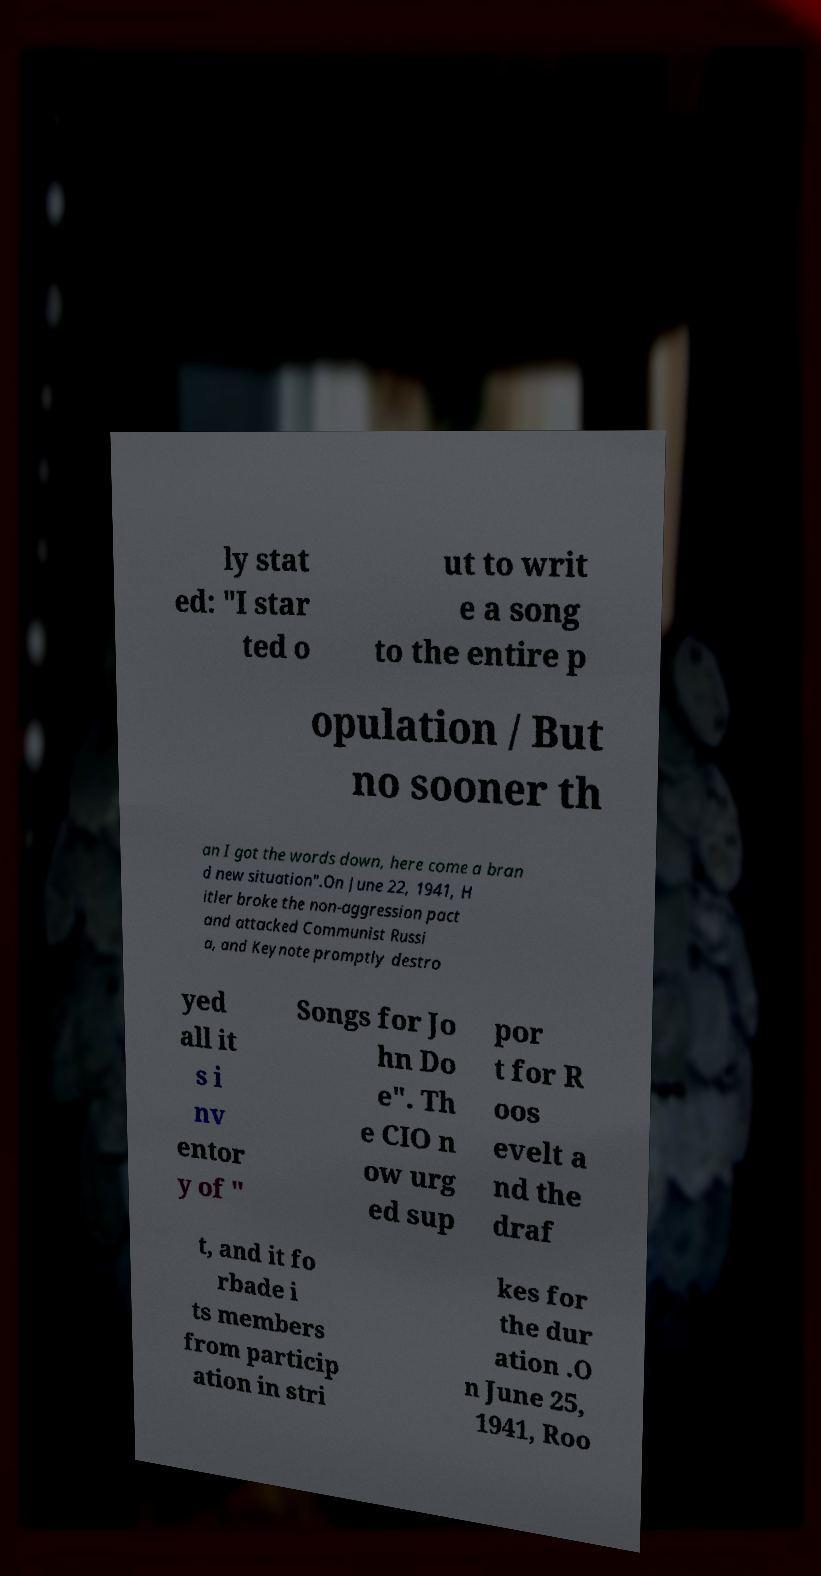For documentation purposes, I need the text within this image transcribed. Could you provide that? ly stat ed: "I star ted o ut to writ e a song to the entire p opulation / But no sooner th an I got the words down, here come a bran d new situation".On June 22, 1941, H itler broke the non-aggression pact and attacked Communist Russi a, and Keynote promptly destro yed all it s i nv entor y of " Songs for Jo hn Do e". Th e CIO n ow urg ed sup por t for R oos evelt a nd the draf t, and it fo rbade i ts members from particip ation in stri kes for the dur ation .O n June 25, 1941, Roo 